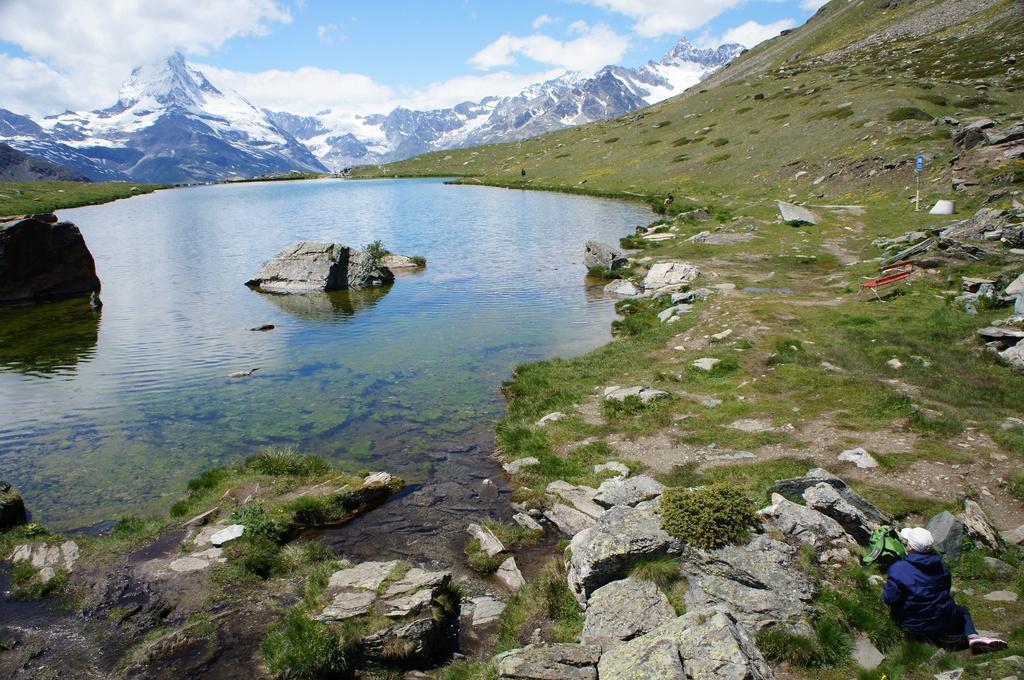Describe this image in one or two sentences. At the bottom of the image there are some stones and grass. In the bottom right side of the image a person is sitting. In the middle of the image there is water, in the water there are some stones. At the top of the image there are some hills and clouds in the sky. 